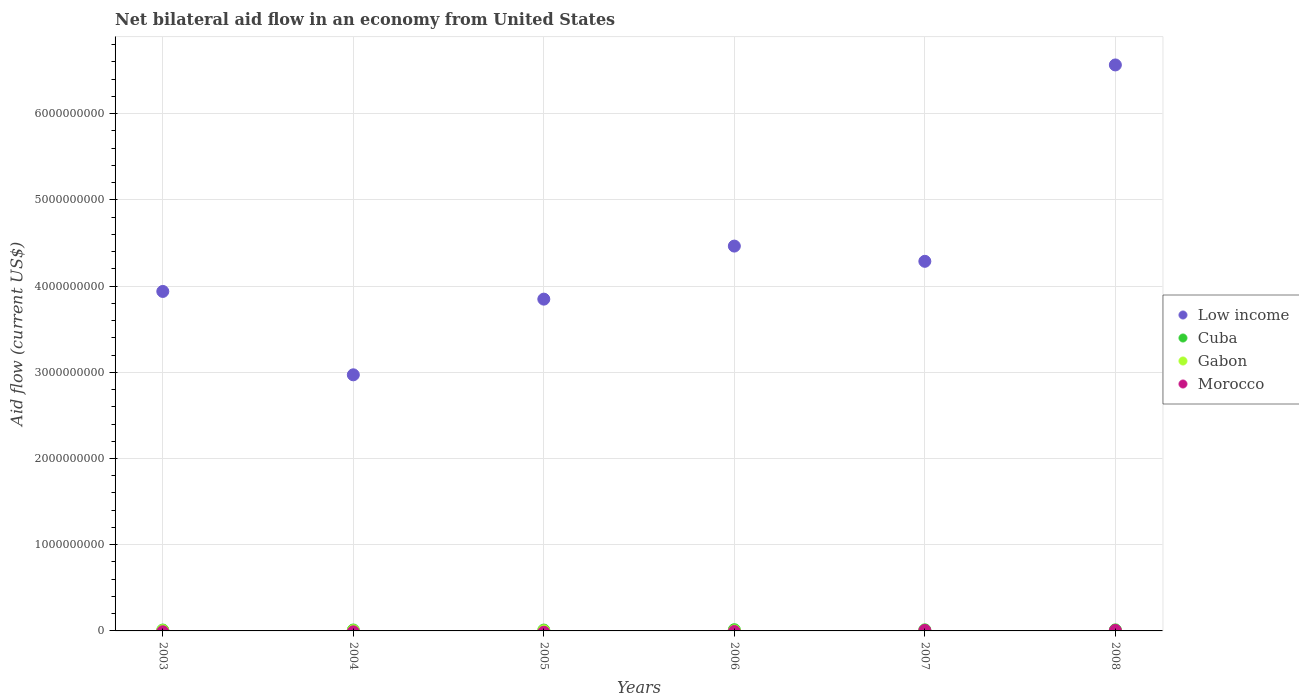How many different coloured dotlines are there?
Your answer should be very brief. 4. Is the number of dotlines equal to the number of legend labels?
Provide a short and direct response. No. What is the net bilateral aid flow in Cuba in 2003?
Your response must be concise. 1.02e+07. Across all years, what is the maximum net bilateral aid flow in Morocco?
Your answer should be very brief. 5.68e+06. In which year was the net bilateral aid flow in Cuba maximum?
Your answer should be very brief. 2006. What is the total net bilateral aid flow in Cuba in the graph?
Keep it short and to the point. 6.89e+07. What is the difference between the net bilateral aid flow in Low income in 2004 and that in 2006?
Ensure brevity in your answer.  -1.49e+09. What is the difference between the net bilateral aid flow in Gabon in 2004 and the net bilateral aid flow in Morocco in 2003?
Your answer should be very brief. 2.88e+06. What is the average net bilateral aid flow in Cuba per year?
Make the answer very short. 1.15e+07. In the year 2008, what is the difference between the net bilateral aid flow in Gabon and net bilateral aid flow in Low income?
Ensure brevity in your answer.  -6.56e+09. What is the ratio of the net bilateral aid flow in Gabon in 2004 to that in 2008?
Offer a terse response. 6. Is the net bilateral aid flow in Cuba in 2003 less than that in 2004?
Keep it short and to the point. Yes. Is the difference between the net bilateral aid flow in Gabon in 2003 and 2004 greater than the difference between the net bilateral aid flow in Low income in 2003 and 2004?
Your answer should be very brief. No. What is the difference between the highest and the second highest net bilateral aid flow in Gabon?
Ensure brevity in your answer.  6.00e+05. What is the difference between the highest and the lowest net bilateral aid flow in Cuba?
Make the answer very short. 4.11e+06. Is it the case that in every year, the sum of the net bilateral aid flow in Morocco and net bilateral aid flow in Gabon  is greater than the sum of net bilateral aid flow in Cuba and net bilateral aid flow in Low income?
Make the answer very short. No. Is it the case that in every year, the sum of the net bilateral aid flow in Morocco and net bilateral aid flow in Cuba  is greater than the net bilateral aid flow in Low income?
Your answer should be compact. No. Is the net bilateral aid flow in Morocco strictly greater than the net bilateral aid flow in Gabon over the years?
Your answer should be compact. No. How many years are there in the graph?
Keep it short and to the point. 6. What is the difference between two consecutive major ticks on the Y-axis?
Keep it short and to the point. 1.00e+09. Are the values on the major ticks of Y-axis written in scientific E-notation?
Your answer should be compact. No. How many legend labels are there?
Provide a short and direct response. 4. How are the legend labels stacked?
Your answer should be compact. Vertical. What is the title of the graph?
Your answer should be compact. Net bilateral aid flow in an economy from United States. What is the label or title of the X-axis?
Your answer should be very brief. Years. What is the label or title of the Y-axis?
Keep it short and to the point. Aid flow (current US$). What is the Aid flow (current US$) of Low income in 2003?
Your answer should be compact. 3.94e+09. What is the Aid flow (current US$) in Cuba in 2003?
Your answer should be compact. 1.02e+07. What is the Aid flow (current US$) in Gabon in 2003?
Your answer should be very brief. 3.48e+06. What is the Aid flow (current US$) of Morocco in 2003?
Give a very brief answer. 0. What is the Aid flow (current US$) of Low income in 2004?
Your answer should be compact. 2.97e+09. What is the Aid flow (current US$) of Cuba in 2004?
Your answer should be compact. 1.06e+07. What is the Aid flow (current US$) in Gabon in 2004?
Offer a terse response. 2.88e+06. What is the Aid flow (current US$) in Morocco in 2004?
Provide a short and direct response. 0. What is the Aid flow (current US$) in Low income in 2005?
Your answer should be very brief. 3.85e+09. What is the Aid flow (current US$) in Cuba in 2005?
Your response must be concise. 9.84e+06. What is the Aid flow (current US$) in Gabon in 2005?
Provide a short and direct response. 1.79e+06. What is the Aid flow (current US$) of Morocco in 2005?
Provide a succinct answer. 0. What is the Aid flow (current US$) in Low income in 2006?
Ensure brevity in your answer.  4.46e+09. What is the Aid flow (current US$) in Cuba in 2006?
Your answer should be very brief. 1.40e+07. What is the Aid flow (current US$) of Gabon in 2006?
Make the answer very short. 1.13e+06. What is the Aid flow (current US$) in Morocco in 2006?
Give a very brief answer. 0. What is the Aid flow (current US$) of Low income in 2007?
Provide a short and direct response. 4.29e+09. What is the Aid flow (current US$) in Cuba in 2007?
Provide a succinct answer. 1.24e+07. What is the Aid flow (current US$) of Gabon in 2007?
Give a very brief answer. 1.05e+06. What is the Aid flow (current US$) of Morocco in 2007?
Keep it short and to the point. 5.49e+06. What is the Aid flow (current US$) in Low income in 2008?
Make the answer very short. 6.56e+09. What is the Aid flow (current US$) of Cuba in 2008?
Make the answer very short. 1.20e+07. What is the Aid flow (current US$) in Gabon in 2008?
Keep it short and to the point. 4.80e+05. What is the Aid flow (current US$) of Morocco in 2008?
Ensure brevity in your answer.  5.68e+06. Across all years, what is the maximum Aid flow (current US$) in Low income?
Your answer should be very brief. 6.56e+09. Across all years, what is the maximum Aid flow (current US$) of Cuba?
Your answer should be very brief. 1.40e+07. Across all years, what is the maximum Aid flow (current US$) of Gabon?
Your response must be concise. 3.48e+06. Across all years, what is the maximum Aid flow (current US$) of Morocco?
Offer a very short reply. 5.68e+06. Across all years, what is the minimum Aid flow (current US$) in Low income?
Provide a short and direct response. 2.97e+09. Across all years, what is the minimum Aid flow (current US$) in Cuba?
Your response must be concise. 9.84e+06. What is the total Aid flow (current US$) in Low income in the graph?
Give a very brief answer. 2.61e+1. What is the total Aid flow (current US$) in Cuba in the graph?
Keep it short and to the point. 6.89e+07. What is the total Aid flow (current US$) of Gabon in the graph?
Offer a very short reply. 1.08e+07. What is the total Aid flow (current US$) in Morocco in the graph?
Ensure brevity in your answer.  1.12e+07. What is the difference between the Aid flow (current US$) of Low income in 2003 and that in 2004?
Offer a very short reply. 9.67e+08. What is the difference between the Aid flow (current US$) in Cuba in 2003 and that in 2004?
Keep it short and to the point. -3.80e+05. What is the difference between the Aid flow (current US$) of Low income in 2003 and that in 2005?
Offer a terse response. 8.93e+07. What is the difference between the Aid flow (current US$) of Gabon in 2003 and that in 2005?
Offer a very short reply. 1.69e+06. What is the difference between the Aid flow (current US$) in Low income in 2003 and that in 2006?
Your response must be concise. -5.26e+08. What is the difference between the Aid flow (current US$) in Cuba in 2003 and that in 2006?
Your answer should be very brief. -3.78e+06. What is the difference between the Aid flow (current US$) of Gabon in 2003 and that in 2006?
Provide a succinct answer. 2.35e+06. What is the difference between the Aid flow (current US$) of Low income in 2003 and that in 2007?
Ensure brevity in your answer.  -3.49e+08. What is the difference between the Aid flow (current US$) in Cuba in 2003 and that in 2007?
Keep it short and to the point. -2.22e+06. What is the difference between the Aid flow (current US$) in Gabon in 2003 and that in 2007?
Your response must be concise. 2.43e+06. What is the difference between the Aid flow (current US$) in Low income in 2003 and that in 2008?
Your response must be concise. -2.63e+09. What is the difference between the Aid flow (current US$) of Cuba in 2003 and that in 2008?
Provide a succinct answer. -1.82e+06. What is the difference between the Aid flow (current US$) in Gabon in 2003 and that in 2008?
Provide a succinct answer. 3.00e+06. What is the difference between the Aid flow (current US$) in Low income in 2004 and that in 2005?
Your answer should be very brief. -8.78e+08. What is the difference between the Aid flow (current US$) of Cuba in 2004 and that in 2005?
Ensure brevity in your answer.  7.10e+05. What is the difference between the Aid flow (current US$) of Gabon in 2004 and that in 2005?
Ensure brevity in your answer.  1.09e+06. What is the difference between the Aid flow (current US$) in Low income in 2004 and that in 2006?
Your response must be concise. -1.49e+09. What is the difference between the Aid flow (current US$) of Cuba in 2004 and that in 2006?
Keep it short and to the point. -3.40e+06. What is the difference between the Aid flow (current US$) in Gabon in 2004 and that in 2006?
Ensure brevity in your answer.  1.75e+06. What is the difference between the Aid flow (current US$) of Low income in 2004 and that in 2007?
Provide a succinct answer. -1.32e+09. What is the difference between the Aid flow (current US$) of Cuba in 2004 and that in 2007?
Give a very brief answer. -1.84e+06. What is the difference between the Aid flow (current US$) in Gabon in 2004 and that in 2007?
Your response must be concise. 1.83e+06. What is the difference between the Aid flow (current US$) of Low income in 2004 and that in 2008?
Give a very brief answer. -3.59e+09. What is the difference between the Aid flow (current US$) in Cuba in 2004 and that in 2008?
Provide a short and direct response. -1.44e+06. What is the difference between the Aid flow (current US$) of Gabon in 2004 and that in 2008?
Provide a succinct answer. 2.40e+06. What is the difference between the Aid flow (current US$) of Low income in 2005 and that in 2006?
Ensure brevity in your answer.  -6.15e+08. What is the difference between the Aid flow (current US$) in Cuba in 2005 and that in 2006?
Your answer should be very brief. -4.11e+06. What is the difference between the Aid flow (current US$) in Gabon in 2005 and that in 2006?
Your answer should be very brief. 6.60e+05. What is the difference between the Aid flow (current US$) of Low income in 2005 and that in 2007?
Ensure brevity in your answer.  -4.39e+08. What is the difference between the Aid flow (current US$) of Cuba in 2005 and that in 2007?
Offer a very short reply. -2.55e+06. What is the difference between the Aid flow (current US$) of Gabon in 2005 and that in 2007?
Provide a succinct answer. 7.40e+05. What is the difference between the Aid flow (current US$) of Low income in 2005 and that in 2008?
Your answer should be very brief. -2.72e+09. What is the difference between the Aid flow (current US$) of Cuba in 2005 and that in 2008?
Your response must be concise. -2.15e+06. What is the difference between the Aid flow (current US$) of Gabon in 2005 and that in 2008?
Offer a very short reply. 1.31e+06. What is the difference between the Aid flow (current US$) in Low income in 2006 and that in 2007?
Offer a terse response. 1.77e+08. What is the difference between the Aid flow (current US$) in Cuba in 2006 and that in 2007?
Keep it short and to the point. 1.56e+06. What is the difference between the Aid flow (current US$) of Gabon in 2006 and that in 2007?
Provide a short and direct response. 8.00e+04. What is the difference between the Aid flow (current US$) of Low income in 2006 and that in 2008?
Keep it short and to the point. -2.10e+09. What is the difference between the Aid flow (current US$) in Cuba in 2006 and that in 2008?
Keep it short and to the point. 1.96e+06. What is the difference between the Aid flow (current US$) in Gabon in 2006 and that in 2008?
Ensure brevity in your answer.  6.50e+05. What is the difference between the Aid flow (current US$) in Low income in 2007 and that in 2008?
Offer a terse response. -2.28e+09. What is the difference between the Aid flow (current US$) in Cuba in 2007 and that in 2008?
Offer a terse response. 4.00e+05. What is the difference between the Aid flow (current US$) in Gabon in 2007 and that in 2008?
Offer a terse response. 5.70e+05. What is the difference between the Aid flow (current US$) of Morocco in 2007 and that in 2008?
Ensure brevity in your answer.  -1.90e+05. What is the difference between the Aid flow (current US$) in Low income in 2003 and the Aid flow (current US$) in Cuba in 2004?
Provide a short and direct response. 3.93e+09. What is the difference between the Aid flow (current US$) of Low income in 2003 and the Aid flow (current US$) of Gabon in 2004?
Ensure brevity in your answer.  3.93e+09. What is the difference between the Aid flow (current US$) in Cuba in 2003 and the Aid flow (current US$) in Gabon in 2004?
Your answer should be very brief. 7.29e+06. What is the difference between the Aid flow (current US$) of Low income in 2003 and the Aid flow (current US$) of Cuba in 2005?
Provide a short and direct response. 3.93e+09. What is the difference between the Aid flow (current US$) of Low income in 2003 and the Aid flow (current US$) of Gabon in 2005?
Make the answer very short. 3.94e+09. What is the difference between the Aid flow (current US$) of Cuba in 2003 and the Aid flow (current US$) of Gabon in 2005?
Keep it short and to the point. 8.38e+06. What is the difference between the Aid flow (current US$) in Low income in 2003 and the Aid flow (current US$) in Cuba in 2006?
Make the answer very short. 3.92e+09. What is the difference between the Aid flow (current US$) in Low income in 2003 and the Aid flow (current US$) in Gabon in 2006?
Provide a succinct answer. 3.94e+09. What is the difference between the Aid flow (current US$) of Cuba in 2003 and the Aid flow (current US$) of Gabon in 2006?
Your answer should be compact. 9.04e+06. What is the difference between the Aid flow (current US$) in Low income in 2003 and the Aid flow (current US$) in Cuba in 2007?
Your response must be concise. 3.93e+09. What is the difference between the Aid flow (current US$) in Low income in 2003 and the Aid flow (current US$) in Gabon in 2007?
Offer a terse response. 3.94e+09. What is the difference between the Aid flow (current US$) of Low income in 2003 and the Aid flow (current US$) of Morocco in 2007?
Your answer should be compact. 3.93e+09. What is the difference between the Aid flow (current US$) of Cuba in 2003 and the Aid flow (current US$) of Gabon in 2007?
Ensure brevity in your answer.  9.12e+06. What is the difference between the Aid flow (current US$) in Cuba in 2003 and the Aid flow (current US$) in Morocco in 2007?
Ensure brevity in your answer.  4.68e+06. What is the difference between the Aid flow (current US$) of Gabon in 2003 and the Aid flow (current US$) of Morocco in 2007?
Provide a succinct answer. -2.01e+06. What is the difference between the Aid flow (current US$) in Low income in 2003 and the Aid flow (current US$) in Cuba in 2008?
Your response must be concise. 3.93e+09. What is the difference between the Aid flow (current US$) of Low income in 2003 and the Aid flow (current US$) of Gabon in 2008?
Keep it short and to the point. 3.94e+09. What is the difference between the Aid flow (current US$) in Low income in 2003 and the Aid flow (current US$) in Morocco in 2008?
Your answer should be very brief. 3.93e+09. What is the difference between the Aid flow (current US$) of Cuba in 2003 and the Aid flow (current US$) of Gabon in 2008?
Provide a succinct answer. 9.69e+06. What is the difference between the Aid flow (current US$) in Cuba in 2003 and the Aid flow (current US$) in Morocco in 2008?
Provide a succinct answer. 4.49e+06. What is the difference between the Aid flow (current US$) in Gabon in 2003 and the Aid flow (current US$) in Morocco in 2008?
Provide a short and direct response. -2.20e+06. What is the difference between the Aid flow (current US$) in Low income in 2004 and the Aid flow (current US$) in Cuba in 2005?
Keep it short and to the point. 2.96e+09. What is the difference between the Aid flow (current US$) in Low income in 2004 and the Aid flow (current US$) in Gabon in 2005?
Ensure brevity in your answer.  2.97e+09. What is the difference between the Aid flow (current US$) of Cuba in 2004 and the Aid flow (current US$) of Gabon in 2005?
Your answer should be compact. 8.76e+06. What is the difference between the Aid flow (current US$) of Low income in 2004 and the Aid flow (current US$) of Cuba in 2006?
Ensure brevity in your answer.  2.96e+09. What is the difference between the Aid flow (current US$) in Low income in 2004 and the Aid flow (current US$) in Gabon in 2006?
Your answer should be very brief. 2.97e+09. What is the difference between the Aid flow (current US$) of Cuba in 2004 and the Aid flow (current US$) of Gabon in 2006?
Your answer should be compact. 9.42e+06. What is the difference between the Aid flow (current US$) in Low income in 2004 and the Aid flow (current US$) in Cuba in 2007?
Your answer should be very brief. 2.96e+09. What is the difference between the Aid flow (current US$) in Low income in 2004 and the Aid flow (current US$) in Gabon in 2007?
Your answer should be very brief. 2.97e+09. What is the difference between the Aid flow (current US$) of Low income in 2004 and the Aid flow (current US$) of Morocco in 2007?
Your response must be concise. 2.97e+09. What is the difference between the Aid flow (current US$) of Cuba in 2004 and the Aid flow (current US$) of Gabon in 2007?
Give a very brief answer. 9.50e+06. What is the difference between the Aid flow (current US$) of Cuba in 2004 and the Aid flow (current US$) of Morocco in 2007?
Make the answer very short. 5.06e+06. What is the difference between the Aid flow (current US$) of Gabon in 2004 and the Aid flow (current US$) of Morocco in 2007?
Provide a succinct answer. -2.61e+06. What is the difference between the Aid flow (current US$) in Low income in 2004 and the Aid flow (current US$) in Cuba in 2008?
Keep it short and to the point. 2.96e+09. What is the difference between the Aid flow (current US$) of Low income in 2004 and the Aid flow (current US$) of Gabon in 2008?
Your answer should be compact. 2.97e+09. What is the difference between the Aid flow (current US$) in Low income in 2004 and the Aid flow (current US$) in Morocco in 2008?
Provide a short and direct response. 2.96e+09. What is the difference between the Aid flow (current US$) in Cuba in 2004 and the Aid flow (current US$) in Gabon in 2008?
Make the answer very short. 1.01e+07. What is the difference between the Aid flow (current US$) of Cuba in 2004 and the Aid flow (current US$) of Morocco in 2008?
Give a very brief answer. 4.87e+06. What is the difference between the Aid flow (current US$) of Gabon in 2004 and the Aid flow (current US$) of Morocco in 2008?
Offer a terse response. -2.80e+06. What is the difference between the Aid flow (current US$) of Low income in 2005 and the Aid flow (current US$) of Cuba in 2006?
Offer a very short reply. 3.83e+09. What is the difference between the Aid flow (current US$) in Low income in 2005 and the Aid flow (current US$) in Gabon in 2006?
Give a very brief answer. 3.85e+09. What is the difference between the Aid flow (current US$) of Cuba in 2005 and the Aid flow (current US$) of Gabon in 2006?
Provide a short and direct response. 8.71e+06. What is the difference between the Aid flow (current US$) in Low income in 2005 and the Aid flow (current US$) in Cuba in 2007?
Ensure brevity in your answer.  3.84e+09. What is the difference between the Aid flow (current US$) in Low income in 2005 and the Aid flow (current US$) in Gabon in 2007?
Your answer should be compact. 3.85e+09. What is the difference between the Aid flow (current US$) in Low income in 2005 and the Aid flow (current US$) in Morocco in 2007?
Ensure brevity in your answer.  3.84e+09. What is the difference between the Aid flow (current US$) of Cuba in 2005 and the Aid flow (current US$) of Gabon in 2007?
Offer a terse response. 8.79e+06. What is the difference between the Aid flow (current US$) in Cuba in 2005 and the Aid flow (current US$) in Morocco in 2007?
Give a very brief answer. 4.35e+06. What is the difference between the Aid flow (current US$) in Gabon in 2005 and the Aid flow (current US$) in Morocco in 2007?
Ensure brevity in your answer.  -3.70e+06. What is the difference between the Aid flow (current US$) in Low income in 2005 and the Aid flow (current US$) in Cuba in 2008?
Your answer should be compact. 3.84e+09. What is the difference between the Aid flow (current US$) in Low income in 2005 and the Aid flow (current US$) in Gabon in 2008?
Your response must be concise. 3.85e+09. What is the difference between the Aid flow (current US$) of Low income in 2005 and the Aid flow (current US$) of Morocco in 2008?
Your response must be concise. 3.84e+09. What is the difference between the Aid flow (current US$) in Cuba in 2005 and the Aid flow (current US$) in Gabon in 2008?
Your response must be concise. 9.36e+06. What is the difference between the Aid flow (current US$) of Cuba in 2005 and the Aid flow (current US$) of Morocco in 2008?
Your response must be concise. 4.16e+06. What is the difference between the Aid flow (current US$) in Gabon in 2005 and the Aid flow (current US$) in Morocco in 2008?
Your answer should be compact. -3.89e+06. What is the difference between the Aid flow (current US$) in Low income in 2006 and the Aid flow (current US$) in Cuba in 2007?
Keep it short and to the point. 4.45e+09. What is the difference between the Aid flow (current US$) in Low income in 2006 and the Aid flow (current US$) in Gabon in 2007?
Make the answer very short. 4.46e+09. What is the difference between the Aid flow (current US$) of Low income in 2006 and the Aid flow (current US$) of Morocco in 2007?
Keep it short and to the point. 4.46e+09. What is the difference between the Aid flow (current US$) in Cuba in 2006 and the Aid flow (current US$) in Gabon in 2007?
Offer a terse response. 1.29e+07. What is the difference between the Aid flow (current US$) of Cuba in 2006 and the Aid flow (current US$) of Morocco in 2007?
Ensure brevity in your answer.  8.46e+06. What is the difference between the Aid flow (current US$) of Gabon in 2006 and the Aid flow (current US$) of Morocco in 2007?
Your answer should be compact. -4.36e+06. What is the difference between the Aid flow (current US$) of Low income in 2006 and the Aid flow (current US$) of Cuba in 2008?
Give a very brief answer. 4.45e+09. What is the difference between the Aid flow (current US$) in Low income in 2006 and the Aid flow (current US$) in Gabon in 2008?
Your response must be concise. 4.46e+09. What is the difference between the Aid flow (current US$) of Low income in 2006 and the Aid flow (current US$) of Morocco in 2008?
Your response must be concise. 4.46e+09. What is the difference between the Aid flow (current US$) in Cuba in 2006 and the Aid flow (current US$) in Gabon in 2008?
Make the answer very short. 1.35e+07. What is the difference between the Aid flow (current US$) in Cuba in 2006 and the Aid flow (current US$) in Morocco in 2008?
Give a very brief answer. 8.27e+06. What is the difference between the Aid flow (current US$) of Gabon in 2006 and the Aid flow (current US$) of Morocco in 2008?
Offer a terse response. -4.55e+06. What is the difference between the Aid flow (current US$) of Low income in 2007 and the Aid flow (current US$) of Cuba in 2008?
Provide a short and direct response. 4.28e+09. What is the difference between the Aid flow (current US$) of Low income in 2007 and the Aid flow (current US$) of Gabon in 2008?
Offer a terse response. 4.29e+09. What is the difference between the Aid flow (current US$) in Low income in 2007 and the Aid flow (current US$) in Morocco in 2008?
Provide a short and direct response. 4.28e+09. What is the difference between the Aid flow (current US$) of Cuba in 2007 and the Aid flow (current US$) of Gabon in 2008?
Make the answer very short. 1.19e+07. What is the difference between the Aid flow (current US$) in Cuba in 2007 and the Aid flow (current US$) in Morocco in 2008?
Your response must be concise. 6.71e+06. What is the difference between the Aid flow (current US$) of Gabon in 2007 and the Aid flow (current US$) of Morocco in 2008?
Your response must be concise. -4.63e+06. What is the average Aid flow (current US$) in Low income per year?
Your answer should be very brief. 4.35e+09. What is the average Aid flow (current US$) of Cuba per year?
Offer a very short reply. 1.15e+07. What is the average Aid flow (current US$) in Gabon per year?
Offer a very short reply. 1.80e+06. What is the average Aid flow (current US$) of Morocco per year?
Ensure brevity in your answer.  1.86e+06. In the year 2003, what is the difference between the Aid flow (current US$) in Low income and Aid flow (current US$) in Cuba?
Make the answer very short. 3.93e+09. In the year 2003, what is the difference between the Aid flow (current US$) of Low income and Aid flow (current US$) of Gabon?
Give a very brief answer. 3.93e+09. In the year 2003, what is the difference between the Aid flow (current US$) of Cuba and Aid flow (current US$) of Gabon?
Keep it short and to the point. 6.69e+06. In the year 2004, what is the difference between the Aid flow (current US$) of Low income and Aid flow (current US$) of Cuba?
Keep it short and to the point. 2.96e+09. In the year 2004, what is the difference between the Aid flow (current US$) in Low income and Aid flow (current US$) in Gabon?
Keep it short and to the point. 2.97e+09. In the year 2004, what is the difference between the Aid flow (current US$) of Cuba and Aid flow (current US$) of Gabon?
Your response must be concise. 7.67e+06. In the year 2005, what is the difference between the Aid flow (current US$) in Low income and Aid flow (current US$) in Cuba?
Provide a succinct answer. 3.84e+09. In the year 2005, what is the difference between the Aid flow (current US$) of Low income and Aid flow (current US$) of Gabon?
Offer a terse response. 3.85e+09. In the year 2005, what is the difference between the Aid flow (current US$) of Cuba and Aid flow (current US$) of Gabon?
Provide a short and direct response. 8.05e+06. In the year 2006, what is the difference between the Aid flow (current US$) in Low income and Aid flow (current US$) in Cuba?
Provide a succinct answer. 4.45e+09. In the year 2006, what is the difference between the Aid flow (current US$) in Low income and Aid flow (current US$) in Gabon?
Ensure brevity in your answer.  4.46e+09. In the year 2006, what is the difference between the Aid flow (current US$) in Cuba and Aid flow (current US$) in Gabon?
Your answer should be compact. 1.28e+07. In the year 2007, what is the difference between the Aid flow (current US$) in Low income and Aid flow (current US$) in Cuba?
Your response must be concise. 4.27e+09. In the year 2007, what is the difference between the Aid flow (current US$) in Low income and Aid flow (current US$) in Gabon?
Provide a succinct answer. 4.29e+09. In the year 2007, what is the difference between the Aid flow (current US$) of Low income and Aid flow (current US$) of Morocco?
Offer a terse response. 4.28e+09. In the year 2007, what is the difference between the Aid flow (current US$) of Cuba and Aid flow (current US$) of Gabon?
Ensure brevity in your answer.  1.13e+07. In the year 2007, what is the difference between the Aid flow (current US$) of Cuba and Aid flow (current US$) of Morocco?
Provide a short and direct response. 6.90e+06. In the year 2007, what is the difference between the Aid flow (current US$) of Gabon and Aid flow (current US$) of Morocco?
Offer a very short reply. -4.44e+06. In the year 2008, what is the difference between the Aid flow (current US$) in Low income and Aid flow (current US$) in Cuba?
Offer a very short reply. 6.55e+09. In the year 2008, what is the difference between the Aid flow (current US$) in Low income and Aid flow (current US$) in Gabon?
Provide a succinct answer. 6.56e+09. In the year 2008, what is the difference between the Aid flow (current US$) of Low income and Aid flow (current US$) of Morocco?
Provide a succinct answer. 6.56e+09. In the year 2008, what is the difference between the Aid flow (current US$) of Cuba and Aid flow (current US$) of Gabon?
Give a very brief answer. 1.15e+07. In the year 2008, what is the difference between the Aid flow (current US$) of Cuba and Aid flow (current US$) of Morocco?
Keep it short and to the point. 6.31e+06. In the year 2008, what is the difference between the Aid flow (current US$) of Gabon and Aid flow (current US$) of Morocco?
Offer a terse response. -5.20e+06. What is the ratio of the Aid flow (current US$) of Low income in 2003 to that in 2004?
Provide a short and direct response. 1.33. What is the ratio of the Aid flow (current US$) in Gabon in 2003 to that in 2004?
Provide a succinct answer. 1.21. What is the ratio of the Aid flow (current US$) in Low income in 2003 to that in 2005?
Ensure brevity in your answer.  1.02. What is the ratio of the Aid flow (current US$) of Cuba in 2003 to that in 2005?
Provide a short and direct response. 1.03. What is the ratio of the Aid flow (current US$) of Gabon in 2003 to that in 2005?
Keep it short and to the point. 1.94. What is the ratio of the Aid flow (current US$) of Low income in 2003 to that in 2006?
Your answer should be very brief. 0.88. What is the ratio of the Aid flow (current US$) of Cuba in 2003 to that in 2006?
Provide a succinct answer. 0.73. What is the ratio of the Aid flow (current US$) in Gabon in 2003 to that in 2006?
Your answer should be very brief. 3.08. What is the ratio of the Aid flow (current US$) in Low income in 2003 to that in 2007?
Offer a very short reply. 0.92. What is the ratio of the Aid flow (current US$) of Cuba in 2003 to that in 2007?
Your answer should be compact. 0.82. What is the ratio of the Aid flow (current US$) of Gabon in 2003 to that in 2007?
Your answer should be very brief. 3.31. What is the ratio of the Aid flow (current US$) of Low income in 2003 to that in 2008?
Keep it short and to the point. 0.6. What is the ratio of the Aid flow (current US$) of Cuba in 2003 to that in 2008?
Keep it short and to the point. 0.85. What is the ratio of the Aid flow (current US$) in Gabon in 2003 to that in 2008?
Make the answer very short. 7.25. What is the ratio of the Aid flow (current US$) in Low income in 2004 to that in 2005?
Make the answer very short. 0.77. What is the ratio of the Aid flow (current US$) in Cuba in 2004 to that in 2005?
Give a very brief answer. 1.07. What is the ratio of the Aid flow (current US$) of Gabon in 2004 to that in 2005?
Ensure brevity in your answer.  1.61. What is the ratio of the Aid flow (current US$) in Low income in 2004 to that in 2006?
Keep it short and to the point. 0.67. What is the ratio of the Aid flow (current US$) of Cuba in 2004 to that in 2006?
Your answer should be compact. 0.76. What is the ratio of the Aid flow (current US$) of Gabon in 2004 to that in 2006?
Give a very brief answer. 2.55. What is the ratio of the Aid flow (current US$) in Low income in 2004 to that in 2007?
Keep it short and to the point. 0.69. What is the ratio of the Aid flow (current US$) of Cuba in 2004 to that in 2007?
Give a very brief answer. 0.85. What is the ratio of the Aid flow (current US$) of Gabon in 2004 to that in 2007?
Provide a succinct answer. 2.74. What is the ratio of the Aid flow (current US$) of Low income in 2004 to that in 2008?
Offer a terse response. 0.45. What is the ratio of the Aid flow (current US$) of Cuba in 2004 to that in 2008?
Your answer should be very brief. 0.88. What is the ratio of the Aid flow (current US$) of Gabon in 2004 to that in 2008?
Keep it short and to the point. 6. What is the ratio of the Aid flow (current US$) of Low income in 2005 to that in 2006?
Your answer should be very brief. 0.86. What is the ratio of the Aid flow (current US$) in Cuba in 2005 to that in 2006?
Offer a very short reply. 0.71. What is the ratio of the Aid flow (current US$) of Gabon in 2005 to that in 2006?
Provide a short and direct response. 1.58. What is the ratio of the Aid flow (current US$) in Low income in 2005 to that in 2007?
Provide a succinct answer. 0.9. What is the ratio of the Aid flow (current US$) of Cuba in 2005 to that in 2007?
Ensure brevity in your answer.  0.79. What is the ratio of the Aid flow (current US$) in Gabon in 2005 to that in 2007?
Your answer should be compact. 1.7. What is the ratio of the Aid flow (current US$) of Low income in 2005 to that in 2008?
Your response must be concise. 0.59. What is the ratio of the Aid flow (current US$) of Cuba in 2005 to that in 2008?
Offer a very short reply. 0.82. What is the ratio of the Aid flow (current US$) in Gabon in 2005 to that in 2008?
Your response must be concise. 3.73. What is the ratio of the Aid flow (current US$) of Low income in 2006 to that in 2007?
Provide a succinct answer. 1.04. What is the ratio of the Aid flow (current US$) in Cuba in 2006 to that in 2007?
Make the answer very short. 1.13. What is the ratio of the Aid flow (current US$) in Gabon in 2006 to that in 2007?
Keep it short and to the point. 1.08. What is the ratio of the Aid flow (current US$) of Low income in 2006 to that in 2008?
Your response must be concise. 0.68. What is the ratio of the Aid flow (current US$) in Cuba in 2006 to that in 2008?
Provide a short and direct response. 1.16. What is the ratio of the Aid flow (current US$) of Gabon in 2006 to that in 2008?
Make the answer very short. 2.35. What is the ratio of the Aid flow (current US$) in Low income in 2007 to that in 2008?
Make the answer very short. 0.65. What is the ratio of the Aid flow (current US$) of Cuba in 2007 to that in 2008?
Your answer should be compact. 1.03. What is the ratio of the Aid flow (current US$) in Gabon in 2007 to that in 2008?
Your response must be concise. 2.19. What is the ratio of the Aid flow (current US$) in Morocco in 2007 to that in 2008?
Keep it short and to the point. 0.97. What is the difference between the highest and the second highest Aid flow (current US$) of Low income?
Offer a terse response. 2.10e+09. What is the difference between the highest and the second highest Aid flow (current US$) of Cuba?
Keep it short and to the point. 1.56e+06. What is the difference between the highest and the second highest Aid flow (current US$) in Gabon?
Your answer should be very brief. 6.00e+05. What is the difference between the highest and the lowest Aid flow (current US$) of Low income?
Keep it short and to the point. 3.59e+09. What is the difference between the highest and the lowest Aid flow (current US$) of Cuba?
Your response must be concise. 4.11e+06. What is the difference between the highest and the lowest Aid flow (current US$) of Gabon?
Your answer should be very brief. 3.00e+06. What is the difference between the highest and the lowest Aid flow (current US$) of Morocco?
Offer a terse response. 5.68e+06. 